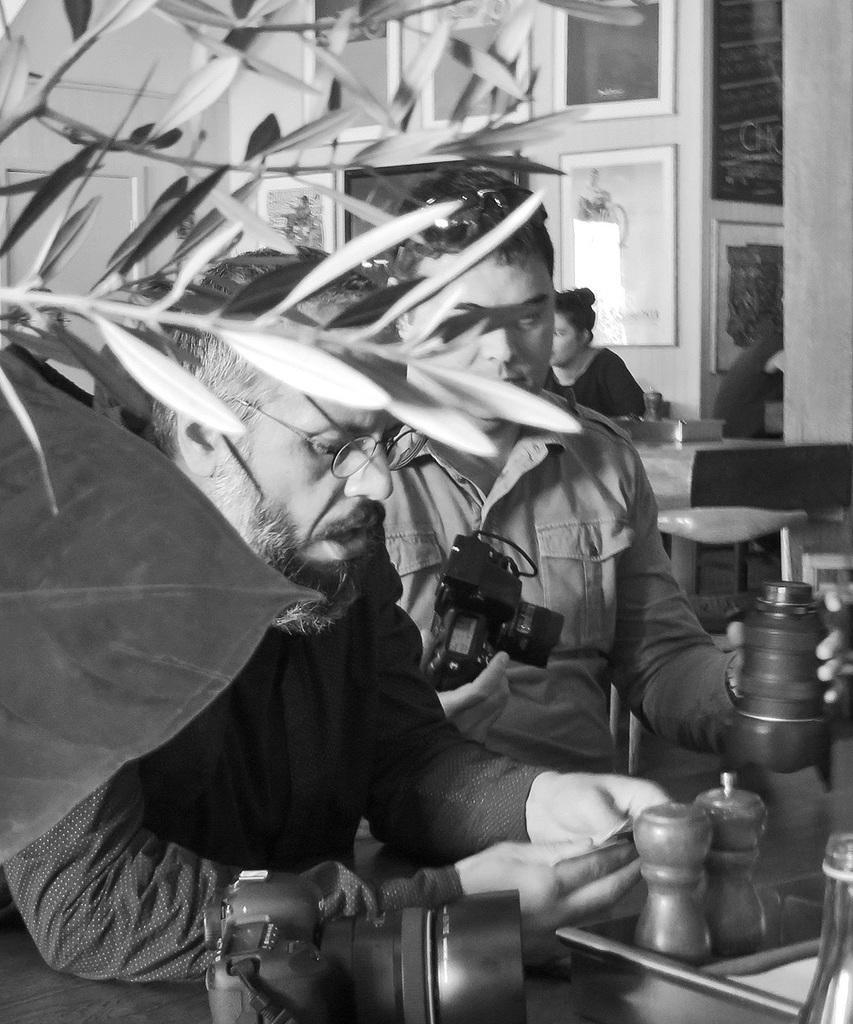How would you summarize this image in a sentence or two? This is a black and white picture. On the left there are stems. In the center of the picture there are two men sitting, in front of them there is a camera. On the right there are bottle and jars. In the background there are tables, frames, door and a woman sitting. 